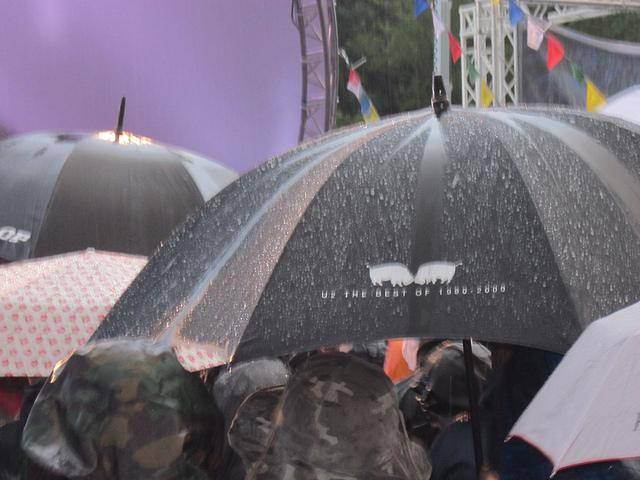What is happening here? Please explain your reasoning. u2 concert. People are in an audience hold flags with the band name u2 on them. u2 gives concerts. 